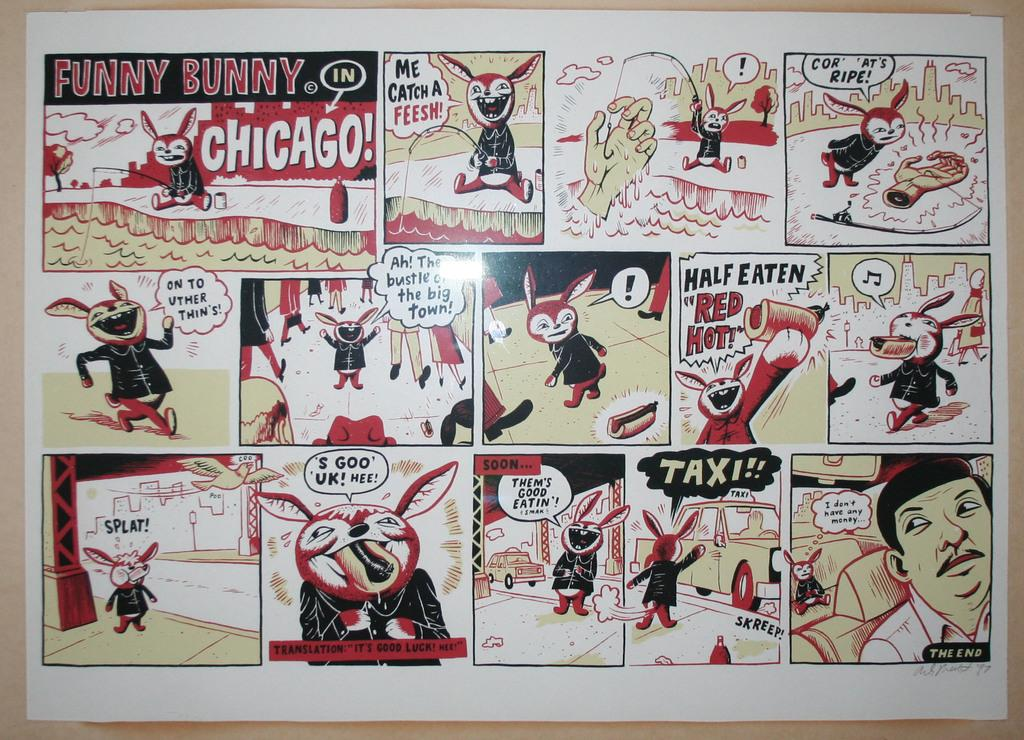<image>
Share a concise interpretation of the image provided. a comic strip of FUNNY BUNNY IN CHICAGO!. 